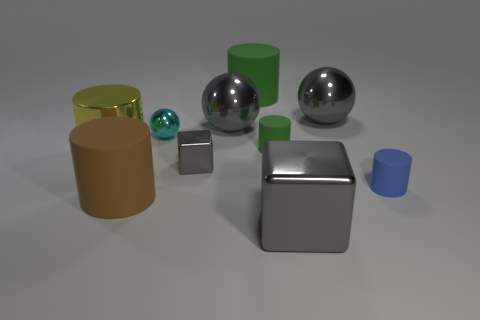Subtract all big gray metal balls. How many balls are left? 1 Subtract 2 cubes. How many cubes are left? 0 Subtract all spheres. How many objects are left? 7 Subtract all yellow cylinders. How many brown spheres are left? 0 Subtract all large brown matte things. Subtract all blue objects. How many objects are left? 8 Add 2 tiny green rubber objects. How many tiny green rubber objects are left? 3 Add 7 yellow rubber cubes. How many yellow rubber cubes exist? 7 Subtract all green cylinders. How many cylinders are left? 3 Subtract 0 purple cylinders. How many objects are left? 10 Subtract all cyan balls. Subtract all red blocks. How many balls are left? 2 